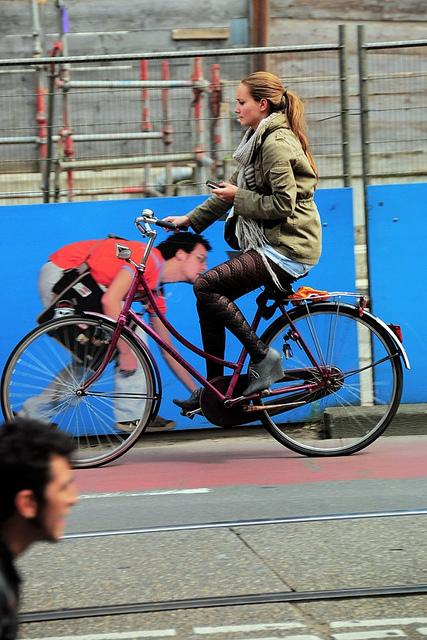What does the object use to speed? pedals 